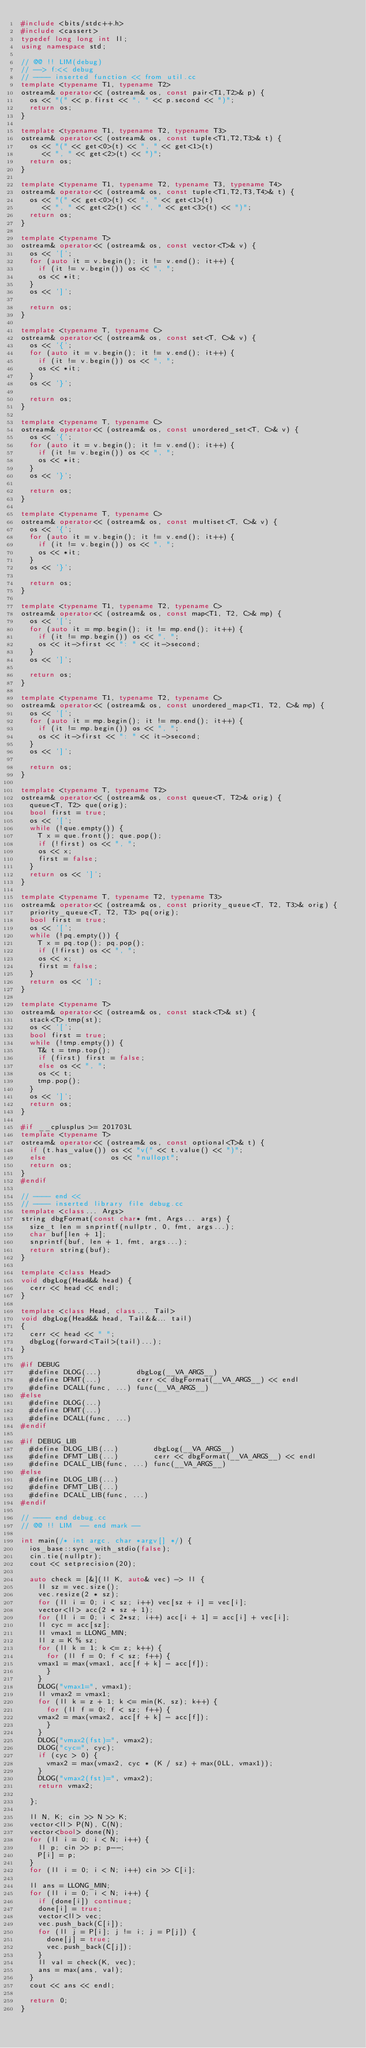<code> <loc_0><loc_0><loc_500><loc_500><_C++_>#include <bits/stdc++.h>
#include <cassert>
typedef long long int ll;
using namespace std;

// @@ !! LIM(debug)
// --> f:<< debug
// ---- inserted function << from util.cc
template <typename T1, typename T2>
ostream& operator<< (ostream& os, const pair<T1,T2>& p) {
  os << "(" << p.first << ", " << p.second << ")";
  return os;
}

template <typename T1, typename T2, typename T3>
ostream& operator<< (ostream& os, const tuple<T1,T2,T3>& t) {
  os << "(" << get<0>(t) << ", " << get<1>(t)
     << ", " << get<2>(t) << ")";
  return os;
}

template <typename T1, typename T2, typename T3, typename T4>
ostream& operator<< (ostream& os, const tuple<T1,T2,T3,T4>& t) {
  os << "(" << get<0>(t) << ", " << get<1>(t)
     << ", " << get<2>(t) << ", " << get<3>(t) << ")";
  return os;
}

template <typename T>
ostream& operator<< (ostream& os, const vector<T>& v) {
  os << '[';
  for (auto it = v.begin(); it != v.end(); it++) {
    if (it != v.begin()) os << ", ";
    os << *it;
  }
  os << ']';

  return os;
}

template <typename T, typename C>
ostream& operator<< (ostream& os, const set<T, C>& v) {
  os << '{';
  for (auto it = v.begin(); it != v.end(); it++) {
    if (it != v.begin()) os << ", ";
    os << *it;
  }
  os << '}';

  return os;
}

template <typename T, typename C>
ostream& operator<< (ostream& os, const unordered_set<T, C>& v) {
  os << '{';
  for (auto it = v.begin(); it != v.end(); it++) {
    if (it != v.begin()) os << ", ";
    os << *it;
  }
  os << '}';

  return os;
}

template <typename T, typename C>
ostream& operator<< (ostream& os, const multiset<T, C>& v) {
  os << '{';
  for (auto it = v.begin(); it != v.end(); it++) {
    if (it != v.begin()) os << ", ";
    os << *it;
  }
  os << '}';

  return os;
}

template <typename T1, typename T2, typename C>
ostream& operator<< (ostream& os, const map<T1, T2, C>& mp) {
  os << '[';
  for (auto it = mp.begin(); it != mp.end(); it++) {
    if (it != mp.begin()) os << ", ";
    os << it->first << ": " << it->second;
  }
  os << ']';

  return os;
}

template <typename T1, typename T2, typename C>
ostream& operator<< (ostream& os, const unordered_map<T1, T2, C>& mp) {
  os << '[';
  for (auto it = mp.begin(); it != mp.end(); it++) {
    if (it != mp.begin()) os << ", ";
    os << it->first << ": " << it->second;
  }
  os << ']';

  return os;
}

template <typename T, typename T2>
ostream& operator<< (ostream& os, const queue<T, T2>& orig) {
  queue<T, T2> que(orig);
  bool first = true;
  os << '[';
  while (!que.empty()) {
    T x = que.front(); que.pop();
    if (!first) os << ", ";
    os << x;
    first = false;
  }
  return os << ']';
}

template <typename T, typename T2, typename T3>
ostream& operator<< (ostream& os, const priority_queue<T, T2, T3>& orig) {
  priority_queue<T, T2, T3> pq(orig);
  bool first = true;
  os << '[';
  while (!pq.empty()) {
    T x = pq.top(); pq.pop();
    if (!first) os << ", ";
    os << x;
    first = false;
  }
  return os << ']';
}

template <typename T>
ostream& operator<< (ostream& os, const stack<T>& st) {
  stack<T> tmp(st);
  os << '[';
  bool first = true;
  while (!tmp.empty()) {
    T& t = tmp.top();
    if (first) first = false;
    else os << ", ";
    os << t;
    tmp.pop();
  }
  os << ']';
  return os;
}

#if __cplusplus >= 201703L
template <typename T>
ostream& operator<< (ostream& os, const optional<T>& t) {
  if (t.has_value()) os << "v(" << t.value() << ")";
  else               os << "nullopt";
  return os;
}
#endif

// ---- end <<
// ---- inserted library file debug.cc
template <class... Args>
string dbgFormat(const char* fmt, Args... args) {
  size_t len = snprintf(nullptr, 0, fmt, args...);
  char buf[len + 1];
  snprintf(buf, len + 1, fmt, args...);
  return string(buf);
}

template <class Head>
void dbgLog(Head&& head) {
  cerr << head << endl;
}

template <class Head, class... Tail>
void dbgLog(Head&& head, Tail&&... tail)
{
  cerr << head << " ";
  dbgLog(forward<Tail>(tail)...);
}

#if DEBUG
  #define DLOG(...)        dbgLog(__VA_ARGS__)
  #define DFMT(...)        cerr << dbgFormat(__VA_ARGS__) << endl
  #define DCALL(func, ...) func(__VA_ARGS__)
#else
  #define DLOG(...)
  #define DFMT(...)
  #define DCALL(func, ...)
#endif

#if DEBUG_LIB
  #define DLOG_LIB(...)        dbgLog(__VA_ARGS__)
  #define DFMT_LIB(...)        cerr << dbgFormat(__VA_ARGS__) << endl
  #define DCALL_LIB(func, ...) func(__VA_ARGS__)
#else
  #define DLOG_LIB(...)
  #define DFMT_LIB(...)
  #define DCALL_LIB(func, ...)
#endif

// ---- end debug.cc
// @@ !! LIM  -- end mark --

int main(/* int argc, char *argv[] */) {
  ios_base::sync_with_stdio(false);
  cin.tie(nullptr);
  cout << setprecision(20);

  auto check = [&](ll K, auto& vec) -> ll {
    ll sz = vec.size();
    vec.resize(2 * sz);
    for (ll i = 0; i < sz; i++) vec[sz + i] = vec[i];
    vector<ll> acc(2 * sz + 1);
    for (ll i = 0; i < 2*sz; i++) acc[i + 1] = acc[i] + vec[i];
    ll cyc = acc[sz];
    ll vmax1 = LLONG_MIN;
    ll z = K % sz;
    for (ll k = 1; k <= z; k++) {
      for (ll f = 0; f < sz; f++) {
	vmax1 = max(vmax1, acc[f + k] - acc[f]);
      }
    }
    DLOG("vmax1=", vmax1);
    ll vmax2 = vmax1;
    for (ll k = z + 1; k <= min(K, sz); k++) {
      for (ll f = 0; f < sz; f++) {
	vmax2 = max(vmax2, acc[f + k] - acc[f]);
      }
    }
    DLOG("vmax2(fst)=", vmax2);
    DLOG("cyc=", cyc);
    if (cyc > 0) {
      vmax2 = max(vmax2, cyc * (K / sz) + max(0LL, vmax1));
    }
    DLOG("vmax2(fst)=", vmax2);
    return vmax2;

  };

  ll N, K; cin >> N >> K;
  vector<ll> P(N), C(N);
  vector<bool> done(N);
  for (ll i = 0; i < N; i++) {
    ll p; cin >> p; p--;
    P[i] = p;
  }
  for (ll i = 0; i < N; i++) cin >> C[i];

  ll ans = LLONG_MIN;
  for (ll i = 0; i < N; i++) {
    if (done[i]) continue;
    done[i] = true;
    vector<ll> vec;
    vec.push_back(C[i]);
    for (ll j = P[i]; j != i; j = P[j]) {
      done[j] = true;
      vec.push_back(C[j]);
    }
    ll val = check(K, vec);
    ans = max(ans, val);
  }
  cout << ans << endl;

  return 0;
}

</code> 